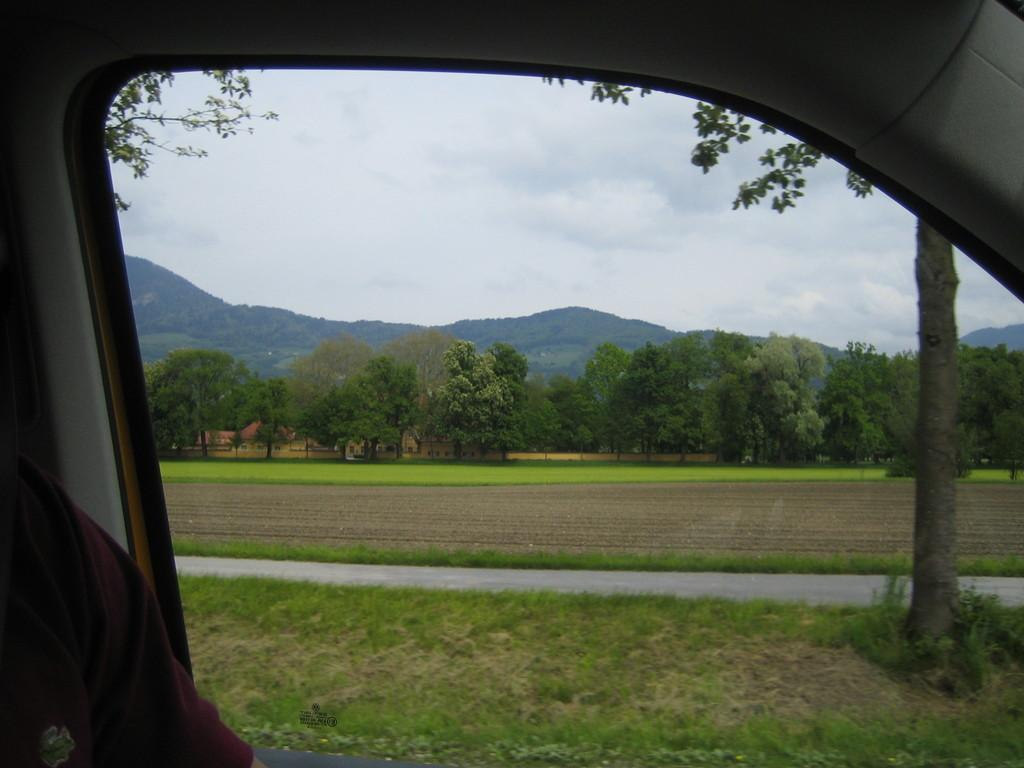What is the main subject of the image? The main subject of the image is a window of a vehicle. What can be seen outside the window? Grass, a road, trees, hills, and a cloudy sky are visible outside the window. Can you describe the landscape outside the window? The landscape includes grass, a road, trees, hills, and a cloudy sky. What type of spark can be seen coming from the vehicle's engine in the image? There is no spark visible in the image, as it only shows a window of a vehicle with a landscape outside. 